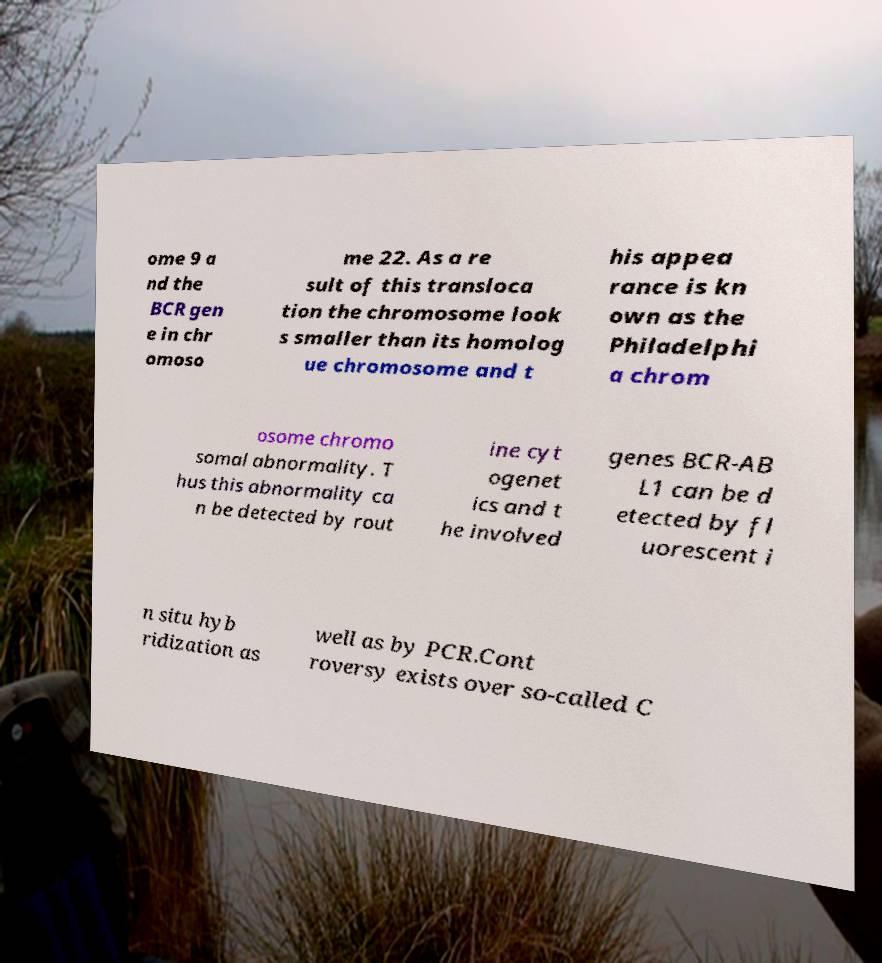Can you read and provide the text displayed in the image?This photo seems to have some interesting text. Can you extract and type it out for me? ome 9 a nd the BCR gen e in chr omoso me 22. As a re sult of this transloca tion the chromosome look s smaller than its homolog ue chromosome and t his appea rance is kn own as the Philadelphi a chrom osome chromo somal abnormality. T hus this abnormality ca n be detected by rout ine cyt ogenet ics and t he involved genes BCR-AB L1 can be d etected by fl uorescent i n situ hyb ridization as well as by PCR.Cont roversy exists over so-called C 